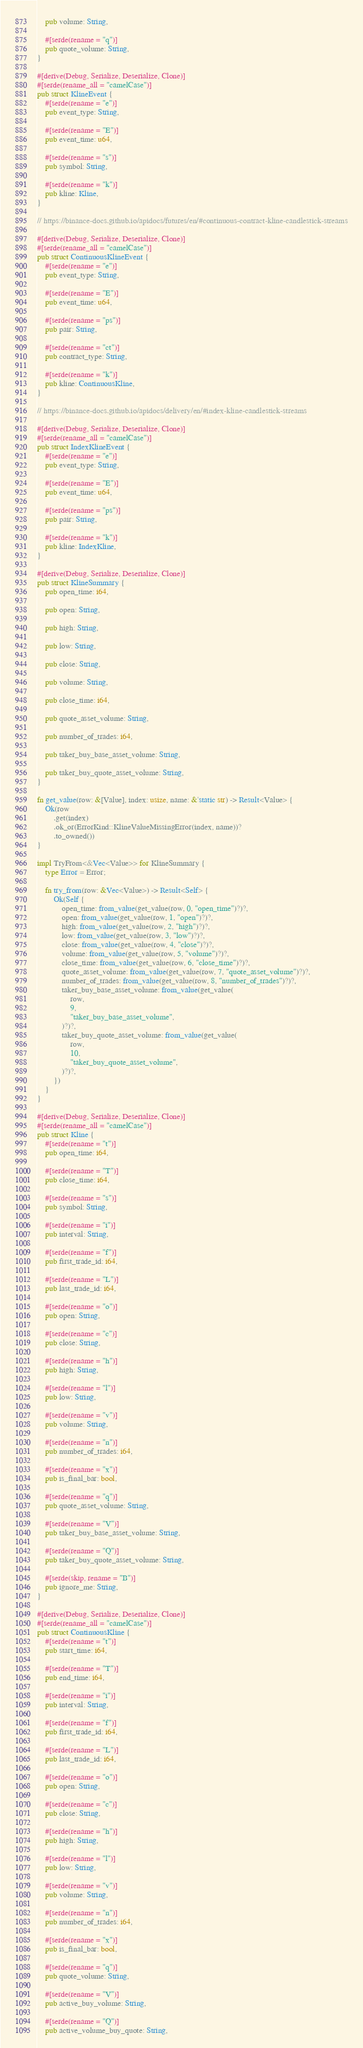Convert code to text. <code><loc_0><loc_0><loc_500><loc_500><_Rust_>    pub volume: String,

    #[serde(rename = "q")]
    pub quote_volume: String,
}

#[derive(Debug, Serialize, Deserialize, Clone)]
#[serde(rename_all = "camelCase")]
pub struct KlineEvent {
    #[serde(rename = "e")]
    pub event_type: String,

    #[serde(rename = "E")]
    pub event_time: u64,

    #[serde(rename = "s")]
    pub symbol: String,

    #[serde(rename = "k")]
    pub kline: Kline,
}

// https://binance-docs.github.io/apidocs/futures/en/#continuous-contract-kline-candlestick-streams

#[derive(Debug, Serialize, Deserialize, Clone)]
#[serde(rename_all = "camelCase")]
pub struct ContinuousKlineEvent {
    #[serde(rename = "e")]
    pub event_type: String,

    #[serde(rename = "E")]
    pub event_time: u64,

    #[serde(rename = "ps")]
    pub pair: String,

    #[serde(rename = "ct")]
    pub contract_type: String,

    #[serde(rename = "k")]
    pub kline: ContinuousKline,
}

// https://binance-docs.github.io/apidocs/delivery/en/#index-kline-candlestick-streams

#[derive(Debug, Serialize, Deserialize, Clone)]
#[serde(rename_all = "camelCase")]
pub struct IndexKlineEvent {
    #[serde(rename = "e")]
    pub event_type: String,

    #[serde(rename = "E")]
    pub event_time: u64,

    #[serde(rename = "ps")]
    pub pair: String,

    #[serde(rename = "k")]
    pub kline: IndexKline,
}

#[derive(Debug, Serialize, Deserialize, Clone)]
pub struct KlineSummary {
    pub open_time: i64,

    pub open: String,

    pub high: String,

    pub low: String,

    pub close: String,

    pub volume: String,

    pub close_time: i64,

    pub quote_asset_volume: String,

    pub number_of_trades: i64,

    pub taker_buy_base_asset_volume: String,

    pub taker_buy_quote_asset_volume: String,
}

fn get_value(row: &[Value], index: usize, name: &'static str) -> Result<Value> {
    Ok(row
        .get(index)
        .ok_or(ErrorKind::KlineValueMissingError(index, name))?
        .to_owned())
}

impl TryFrom<&Vec<Value>> for KlineSummary {
    type Error = Error;

    fn try_from(row: &Vec<Value>) -> Result<Self> {
        Ok(Self {
            open_time: from_value(get_value(row, 0, "open_time")?)?,
            open: from_value(get_value(row, 1, "open")?)?,
            high: from_value(get_value(row, 2, "high")?)?,
            low: from_value(get_value(row, 3, "low")?)?,
            close: from_value(get_value(row, 4, "close")?)?,
            volume: from_value(get_value(row, 5, "volume")?)?,
            close_time: from_value(get_value(row, 6, "close_time")?)?,
            quote_asset_volume: from_value(get_value(row, 7, "quote_asset_volume")?)?,
            number_of_trades: from_value(get_value(row, 8, "number_of_trades")?)?,
            taker_buy_base_asset_volume: from_value(get_value(
                row,
                9,
                "taker_buy_base_asset_volume",
            )?)?,
            taker_buy_quote_asset_volume: from_value(get_value(
                row,
                10,
                "taker_buy_quote_asset_volume",
            )?)?,
        })
    }
}

#[derive(Debug, Serialize, Deserialize, Clone)]
#[serde(rename_all = "camelCase")]
pub struct Kline {
    #[serde(rename = "t")]
    pub open_time: i64,

    #[serde(rename = "T")]
    pub close_time: i64,

    #[serde(rename = "s")]
    pub symbol: String,

    #[serde(rename = "i")]
    pub interval: String,

    #[serde(rename = "f")]
    pub first_trade_id: i64,

    #[serde(rename = "L")]
    pub last_trade_id: i64,

    #[serde(rename = "o")]
    pub open: String,

    #[serde(rename = "c")]
    pub close: String,

    #[serde(rename = "h")]
    pub high: String,

    #[serde(rename = "l")]
    pub low: String,

    #[serde(rename = "v")]
    pub volume: String,

    #[serde(rename = "n")]
    pub number_of_trades: i64,

    #[serde(rename = "x")]
    pub is_final_bar: bool,

    #[serde(rename = "q")]
    pub quote_asset_volume: String,

    #[serde(rename = "V")]
    pub taker_buy_base_asset_volume: String,

    #[serde(rename = "Q")]
    pub taker_buy_quote_asset_volume: String,

    #[serde(skip, rename = "B")]
    pub ignore_me: String,
}

#[derive(Debug, Serialize, Deserialize, Clone)]
#[serde(rename_all = "camelCase")]
pub struct ContinuousKline {
    #[serde(rename = "t")]
    pub start_time: i64,

    #[serde(rename = "T")]
    pub end_time: i64,

    #[serde(rename = "i")]
    pub interval: String,

    #[serde(rename = "f")]
    pub first_trade_id: i64,

    #[serde(rename = "L")]
    pub last_trade_id: i64,

    #[serde(rename = "o")]
    pub open: String,

    #[serde(rename = "c")]
    pub close: String,

    #[serde(rename = "h")]
    pub high: String,

    #[serde(rename = "l")]
    pub low: String,

    #[serde(rename = "v")]
    pub volume: String,

    #[serde(rename = "n")]
    pub number_of_trades: i64,

    #[serde(rename = "x")]
    pub is_final_bar: bool,

    #[serde(rename = "q")]
    pub quote_volume: String,

    #[serde(rename = "V")]
    pub active_buy_volume: String,

    #[serde(rename = "Q")]
    pub active_volume_buy_quote: String,
</code> 